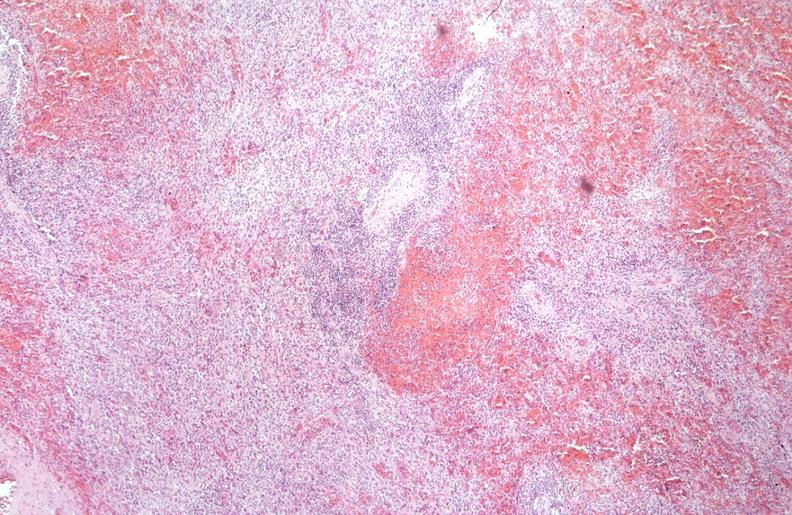does this photo show spleen, chronic congestion due to portal hypertension from cirrhosis, hcv?
Answer the question using a single word or phrase. No 